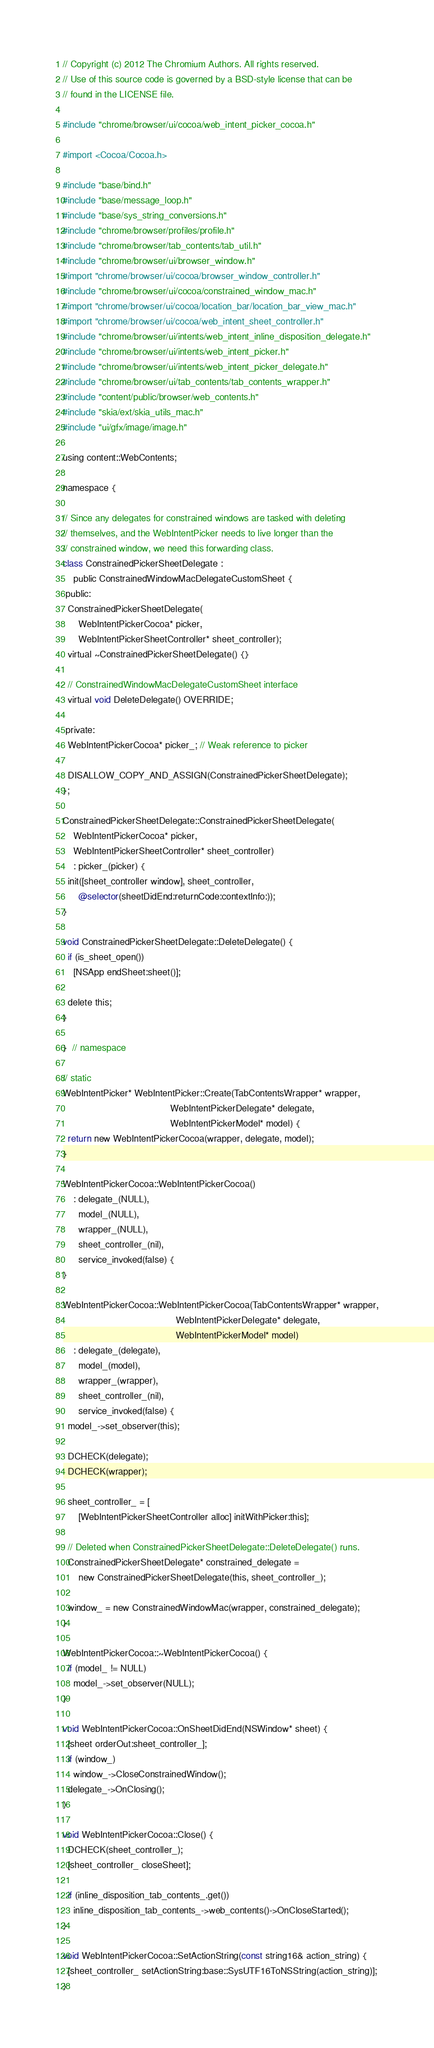Convert code to text. <code><loc_0><loc_0><loc_500><loc_500><_ObjectiveC_>// Copyright (c) 2012 The Chromium Authors. All rights reserved.
// Use of this source code is governed by a BSD-style license that can be
// found in the LICENSE file.

#include "chrome/browser/ui/cocoa/web_intent_picker_cocoa.h"

#import <Cocoa/Cocoa.h>

#include "base/bind.h"
#include "base/message_loop.h"
#include "base/sys_string_conversions.h"
#include "chrome/browser/profiles/profile.h"
#include "chrome/browser/tab_contents/tab_util.h"
#include "chrome/browser/ui/browser_window.h"
#import "chrome/browser/ui/cocoa/browser_window_controller.h"
#include "chrome/browser/ui/cocoa/constrained_window_mac.h"
#import "chrome/browser/ui/cocoa/location_bar/location_bar_view_mac.h"
#import "chrome/browser/ui/cocoa/web_intent_sheet_controller.h"
#include "chrome/browser/ui/intents/web_intent_inline_disposition_delegate.h"
#include "chrome/browser/ui/intents/web_intent_picker.h"
#include "chrome/browser/ui/intents/web_intent_picker_delegate.h"
#include "chrome/browser/ui/tab_contents/tab_contents_wrapper.h"
#include "content/public/browser/web_contents.h"
#include "skia/ext/skia_utils_mac.h"
#include "ui/gfx/image/image.h"

using content::WebContents;

namespace {

// Since any delegates for constrained windows are tasked with deleting
// themselves, and the WebIntentPicker needs to live longer than the
// constrained window, we need this forwarding class.
class ConstrainedPickerSheetDelegate :
    public ConstrainedWindowMacDelegateCustomSheet {
 public:
  ConstrainedPickerSheetDelegate(
      WebIntentPickerCocoa* picker,
      WebIntentPickerSheetController* sheet_controller);
  virtual ~ConstrainedPickerSheetDelegate() {}

  // ConstrainedWindowMacDelegateCustomSheet interface
  virtual void DeleteDelegate() OVERRIDE;

 private:
  WebIntentPickerCocoa* picker_; // Weak reference to picker

  DISALLOW_COPY_AND_ASSIGN(ConstrainedPickerSheetDelegate);
};

ConstrainedPickerSheetDelegate::ConstrainedPickerSheetDelegate(
    WebIntentPickerCocoa* picker,
    WebIntentPickerSheetController* sheet_controller)
    : picker_(picker) {
  init([sheet_controller window], sheet_controller,
      @selector(sheetDidEnd:returnCode:contextInfo:));
}

void ConstrainedPickerSheetDelegate::DeleteDelegate() {
  if (is_sheet_open())
    [NSApp endSheet:sheet()];

  delete this;
}

}  // namespace

// static
WebIntentPicker* WebIntentPicker::Create(TabContentsWrapper* wrapper,
                                         WebIntentPickerDelegate* delegate,
                                         WebIntentPickerModel* model) {
  return new WebIntentPickerCocoa(wrapper, delegate, model);
}

WebIntentPickerCocoa::WebIntentPickerCocoa()
    : delegate_(NULL),
      model_(NULL),
      wrapper_(NULL),
      sheet_controller_(nil),
      service_invoked(false) {
}

WebIntentPickerCocoa::WebIntentPickerCocoa(TabContentsWrapper* wrapper,
                                           WebIntentPickerDelegate* delegate,
                                           WebIntentPickerModel* model)
    : delegate_(delegate),
      model_(model),
      wrapper_(wrapper),
      sheet_controller_(nil),
      service_invoked(false) {
  model_->set_observer(this);

  DCHECK(delegate);
  DCHECK(wrapper);

  sheet_controller_ = [
      [WebIntentPickerSheetController alloc] initWithPicker:this];

  // Deleted when ConstrainedPickerSheetDelegate::DeleteDelegate() runs.
  ConstrainedPickerSheetDelegate* constrained_delegate =
      new ConstrainedPickerSheetDelegate(this, sheet_controller_);

  window_ = new ConstrainedWindowMac(wrapper, constrained_delegate);
}

WebIntentPickerCocoa::~WebIntentPickerCocoa() {
  if (model_ != NULL)
    model_->set_observer(NULL);
}

void WebIntentPickerCocoa::OnSheetDidEnd(NSWindow* sheet) {
  [sheet orderOut:sheet_controller_];
  if (window_)
    window_->CloseConstrainedWindow();
  delegate_->OnClosing();
}

void WebIntentPickerCocoa::Close() {
  DCHECK(sheet_controller_);
  [sheet_controller_ closeSheet];

  if (inline_disposition_tab_contents_.get())
    inline_disposition_tab_contents_->web_contents()->OnCloseStarted();
}

void WebIntentPickerCocoa::SetActionString(const string16& action_string) {
  [sheet_controller_ setActionString:base::SysUTF16ToNSString(action_string)];
}
</code> 